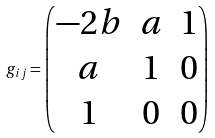Convert formula to latex. <formula><loc_0><loc_0><loc_500><loc_500>g _ { i j } = \begin{pmatrix} - 2 b & a & 1 \\ a & 1 & 0 \\ 1 & 0 & 0 \end{pmatrix}</formula> 